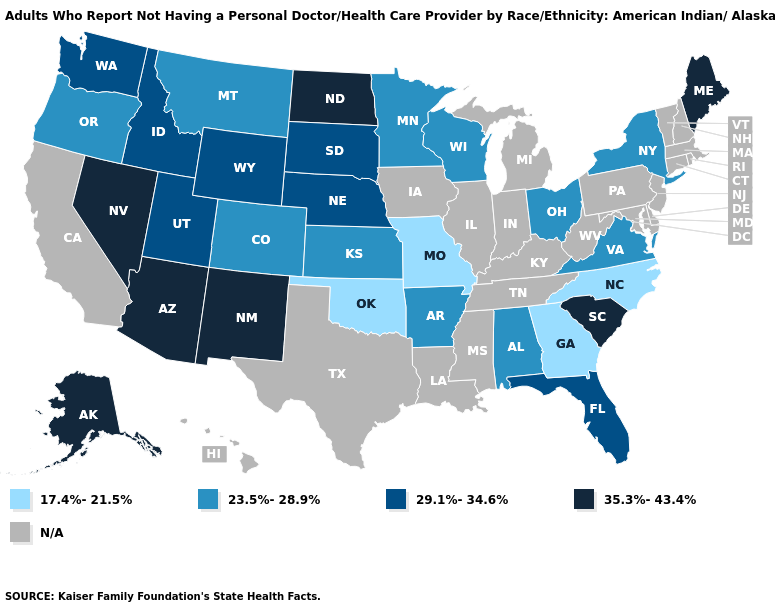Which states have the highest value in the USA?
Write a very short answer. Alaska, Arizona, Maine, Nevada, New Mexico, North Dakota, South Carolina. What is the value of New Hampshire?
Write a very short answer. N/A. Name the states that have a value in the range 29.1%-34.6%?
Keep it brief. Florida, Idaho, Nebraska, South Dakota, Utah, Washington, Wyoming. What is the value of Texas?
Answer briefly. N/A. Which states have the lowest value in the USA?
Keep it brief. Georgia, Missouri, North Carolina, Oklahoma. Name the states that have a value in the range 23.5%-28.9%?
Be succinct. Alabama, Arkansas, Colorado, Kansas, Minnesota, Montana, New York, Ohio, Oregon, Virginia, Wisconsin. Does Arkansas have the lowest value in the South?
Quick response, please. No. Among the states that border Kentucky , which have the highest value?
Concise answer only. Ohio, Virginia. Name the states that have a value in the range 35.3%-43.4%?
Answer briefly. Alaska, Arizona, Maine, Nevada, New Mexico, North Dakota, South Carolina. Among the states that border Massachusetts , which have the highest value?
Answer briefly. New York. Which states hav the highest value in the South?
Keep it brief. South Carolina. Does Alabama have the lowest value in the South?
Concise answer only. No. What is the value of Massachusetts?
Short answer required. N/A. What is the highest value in the South ?
Answer briefly. 35.3%-43.4%. Does the map have missing data?
Give a very brief answer. Yes. 